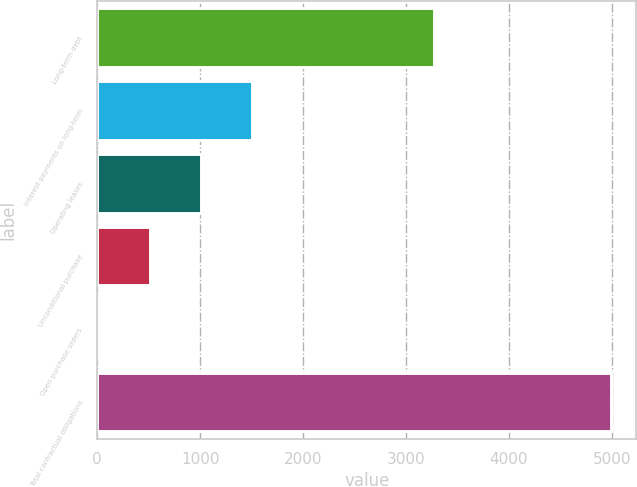Convert chart. <chart><loc_0><loc_0><loc_500><loc_500><bar_chart><fcel>Long-term debt<fcel>Interest payments on long-term<fcel>Operating leases<fcel>Unconditional purchase<fcel>Open purchase orders<fcel>Total contractual obligations<nl><fcel>3272<fcel>1507.5<fcel>1010<fcel>512.5<fcel>15<fcel>4990<nl></chart> 